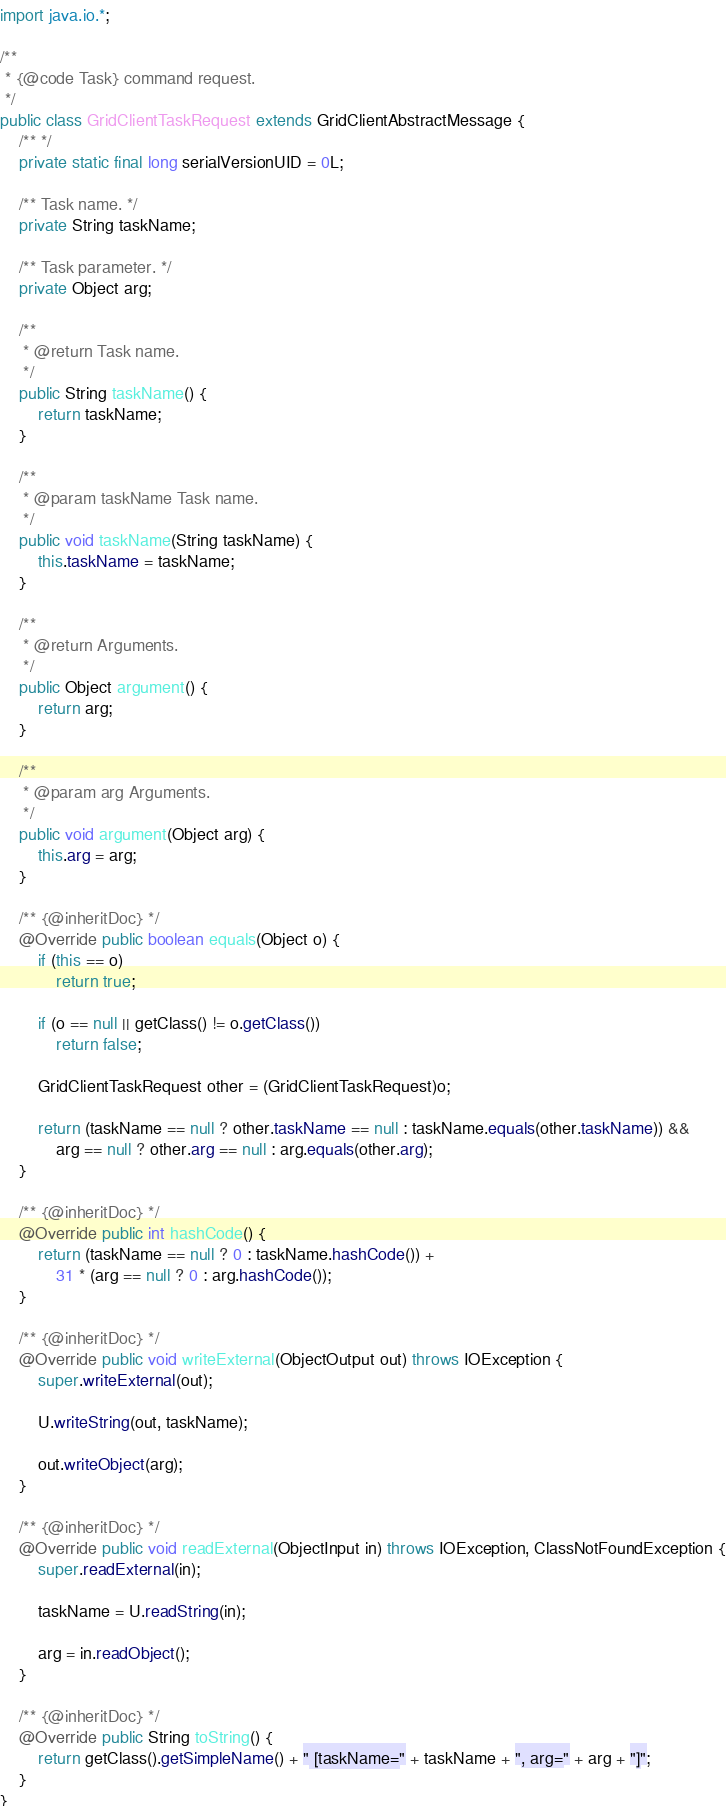Convert code to text. <code><loc_0><loc_0><loc_500><loc_500><_Java_>import java.io.*;

/**
 * {@code Task} command request.
 */
public class GridClientTaskRequest extends GridClientAbstractMessage {
    /** */
    private static final long serialVersionUID = 0L;

    /** Task name. */
    private String taskName;

    /** Task parameter. */
    private Object arg;

    /**
     * @return Task name.
     */
    public String taskName() {
        return taskName;
    }

    /**
     * @param taskName Task name.
     */
    public void taskName(String taskName) {
        this.taskName = taskName;
    }

    /**
     * @return Arguments.
     */
    public Object argument() {
        return arg;
    }

    /**
     * @param arg Arguments.
     */
    public void argument(Object arg) {
        this.arg = arg;
    }

    /** {@inheritDoc} */
    @Override public boolean equals(Object o) {
        if (this == o)
            return true;

        if (o == null || getClass() != o.getClass())
            return false;

        GridClientTaskRequest other = (GridClientTaskRequest)o;

        return (taskName == null ? other.taskName == null : taskName.equals(other.taskName)) &&
            arg == null ? other.arg == null : arg.equals(other.arg);
    }

    /** {@inheritDoc} */
    @Override public int hashCode() {
        return (taskName == null ? 0 : taskName.hashCode()) +
            31 * (arg == null ? 0 : arg.hashCode());
    }

    /** {@inheritDoc} */
    @Override public void writeExternal(ObjectOutput out) throws IOException {
        super.writeExternal(out);

        U.writeString(out, taskName);

        out.writeObject(arg);
    }

    /** {@inheritDoc} */
    @Override public void readExternal(ObjectInput in) throws IOException, ClassNotFoundException {
        super.readExternal(in);

        taskName = U.readString(in);

        arg = in.readObject();
    }

    /** {@inheritDoc} */
    @Override public String toString() {
        return getClass().getSimpleName() + " [taskName=" + taskName + ", arg=" + arg + "]";
    }
}
</code> 